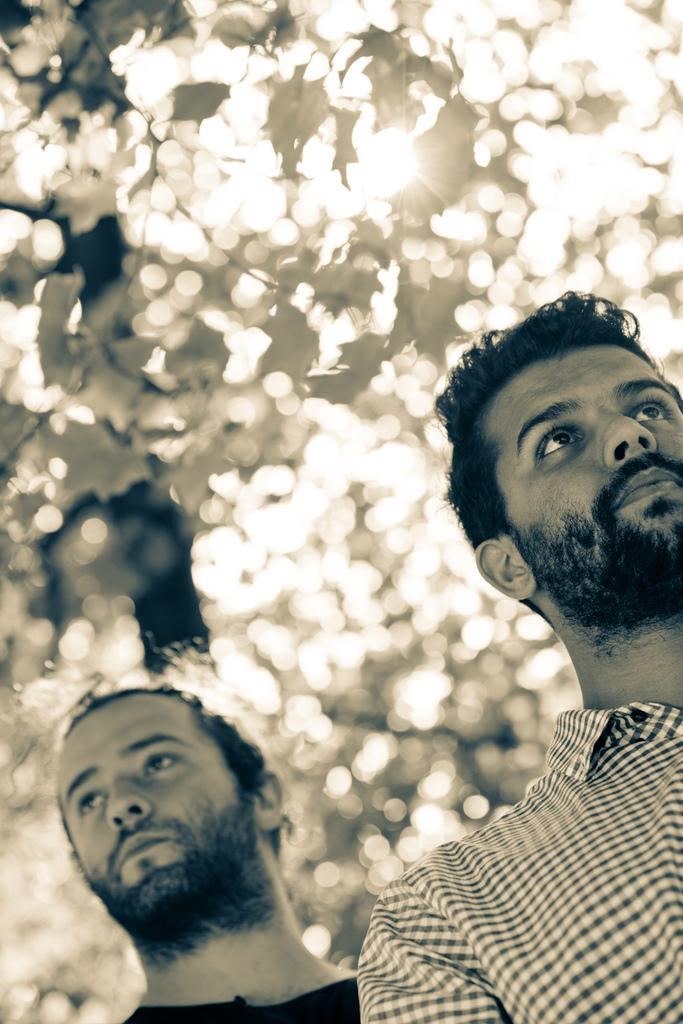How many people are in the image? There are two men in the image. What can be seen in the background of the image? There are trees in the background of the image. What type of paste is being used by the men in the image? There is no paste present in the image; it only features two men and trees in the background. 